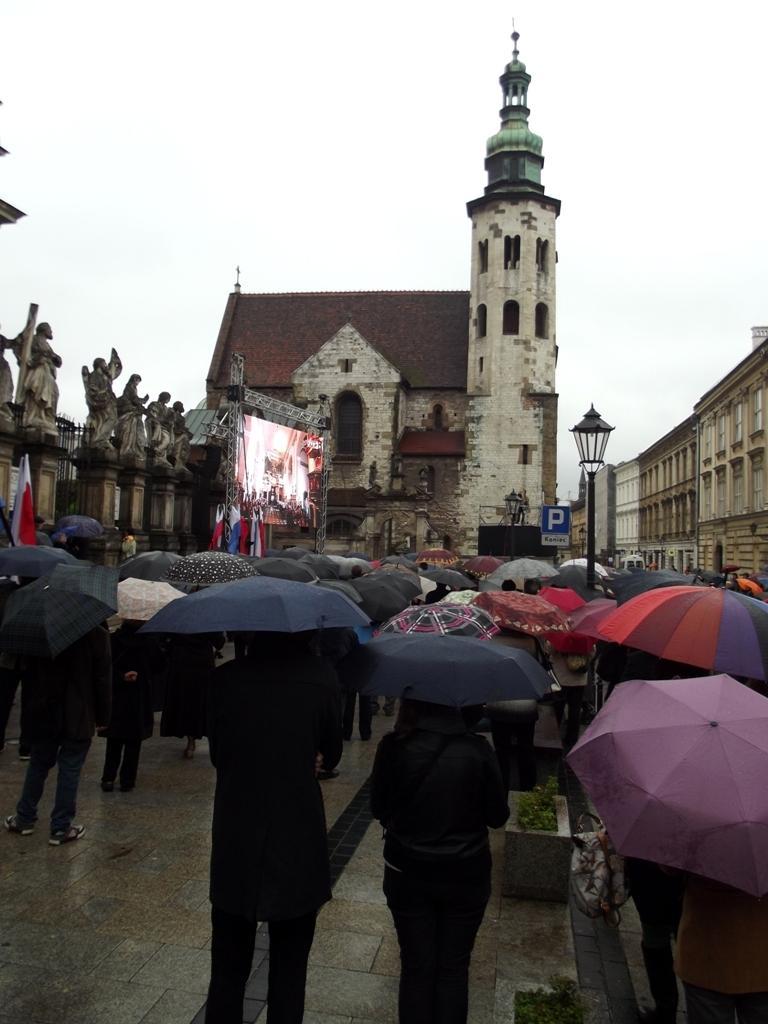Please provide a concise description of this image. In this image I can see number of people are standing and I can see all of them are holding umbrellas. In the background I can see few poles, a light, a sign board, few flags, few sculptures, few buildings, a screen and the sky. 